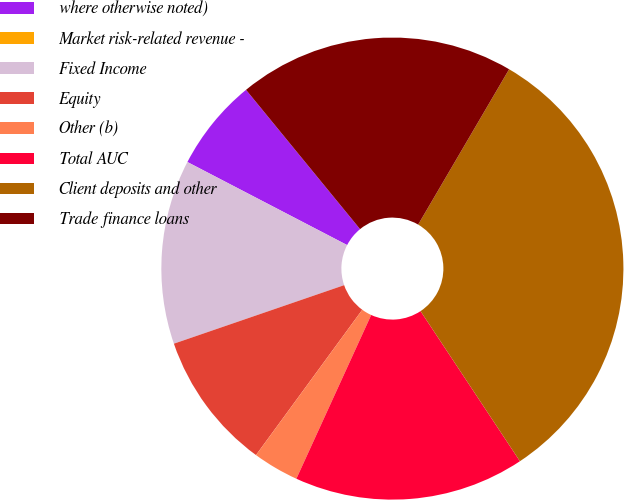<chart> <loc_0><loc_0><loc_500><loc_500><pie_chart><fcel>where otherwise noted)<fcel>Market risk-related revenue -<fcel>Fixed Income<fcel>Equity<fcel>Other (b)<fcel>Total AUC<fcel>Client deposits and other<fcel>Trade finance loans<nl><fcel>6.45%<fcel>0.0%<fcel>12.9%<fcel>9.68%<fcel>3.23%<fcel>16.13%<fcel>32.26%<fcel>19.35%<nl></chart> 